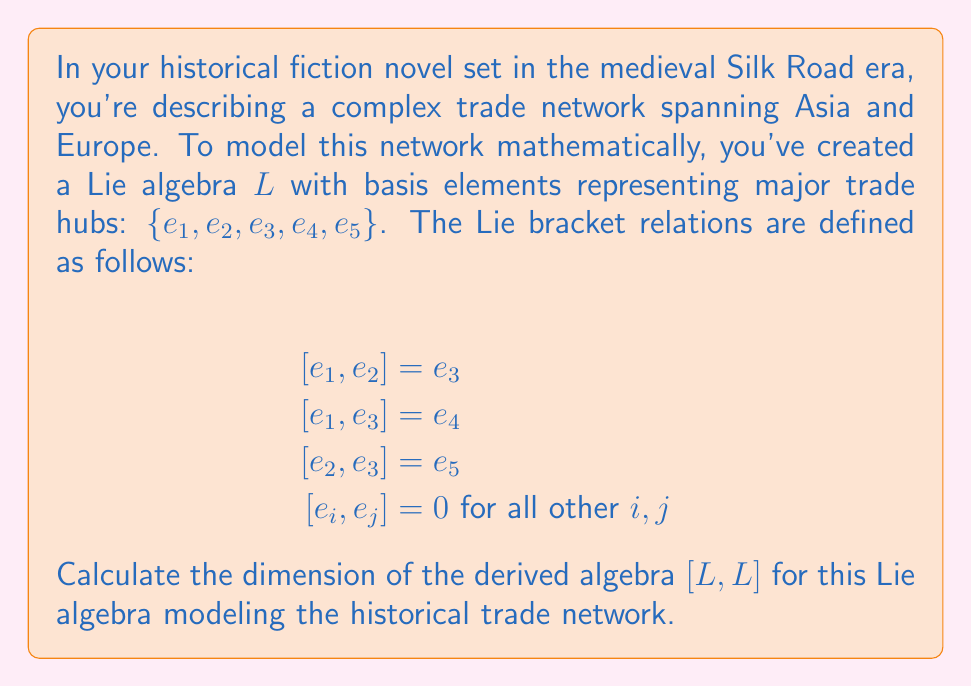What is the answer to this math problem? Let's approach this step-by-step:

1) The derived algebra $[L,L]$ is the subalgebra generated by all Lie brackets $[x,y]$ where $x,y \in L$.

2) From the given Lie bracket relations, we can see that:
   $[L,L] = \text{span}\{[e_1, e_2], [e_1, e_3], [e_2, e_3]\}$

3) Substituting the known relations:
   $[L,L] = \text{span}\{e_3, e_4, e_5\}$

4) To find the dimension of $[L,L]$, we need to determine if these spanning elements are linearly independent.

5) Since $e_3, e_4,$ and $e_5$ are basis elements of the original algebra $L$, they are linearly independent by definition.

6) Therefore, $\{e_3, e_4, e_5\}$ forms a basis for $[L,L]$.

7) The dimension of a vector space is equal to the number of elements in its basis.

8) Thus, the dimension of $[L,L]$ is 3.

This result indicates that the derived algebra, representing the "core" of the trade network interactions, involves three key components or hubs in your historical trade network model.
Answer: 3 